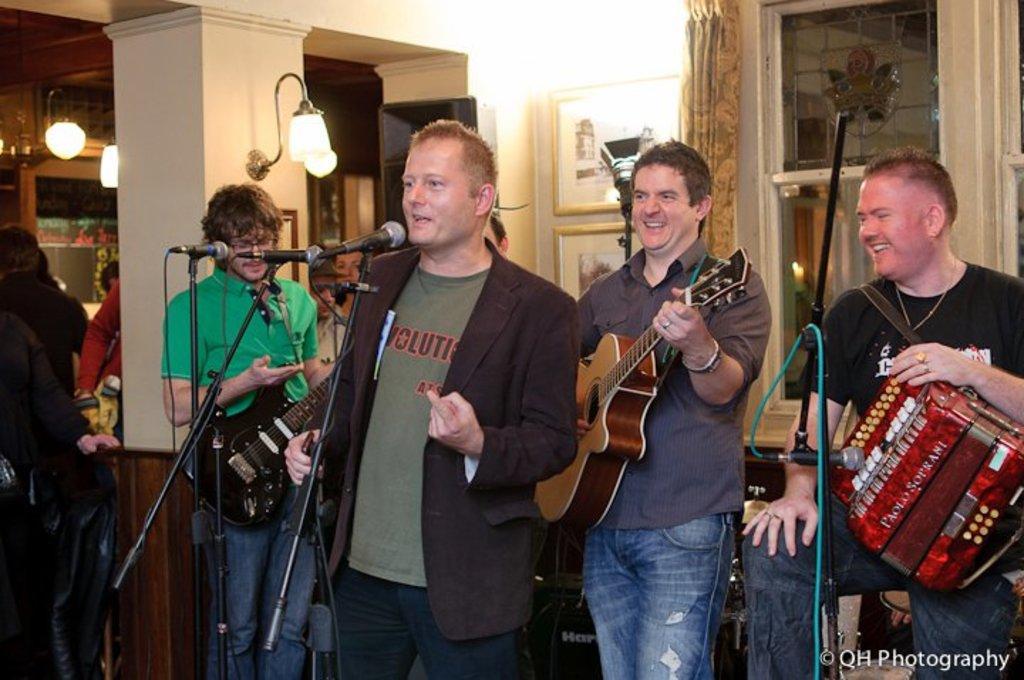Please provide a concise description of this image. In the image we can see there are lot men who are standing and people are holding guitar in their hand and a musical instrument. 